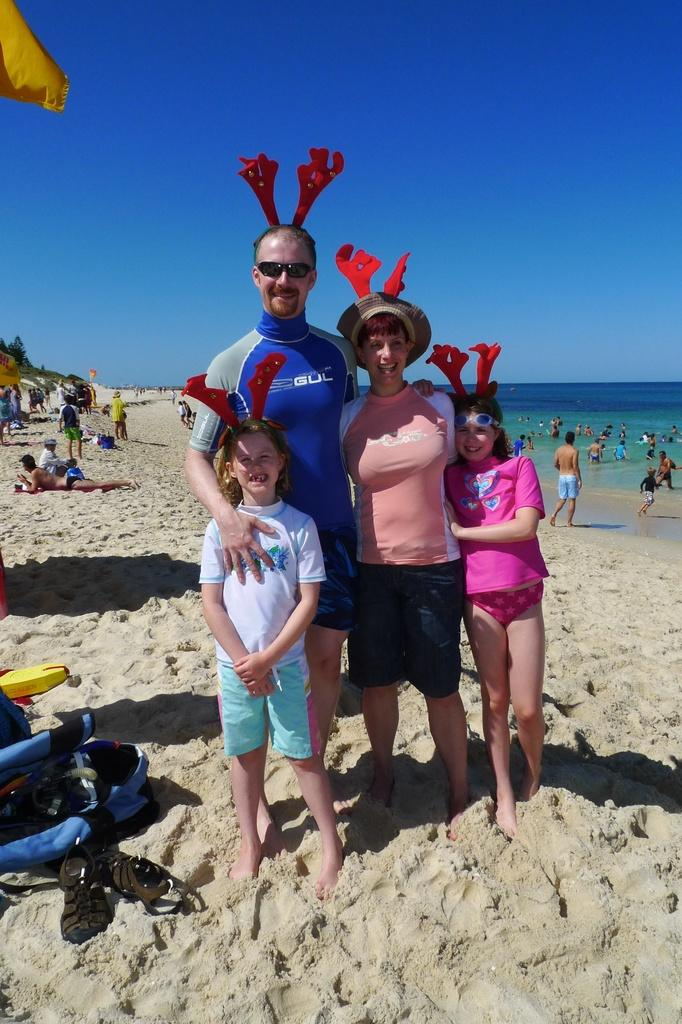Who or what can be seen in the image? There are people in the image. What type of terrain is visible in the image? There is sand visible in the image. What else can be seen in the image besides people and sand? There is water visible in the image. What is visible above the people and terrain in the image? The sky is visible in the image. What type of sink is visible in the image? There is no sink present in the image. What religious event is taking place in the image? There is no indication of a religious event in the image. 